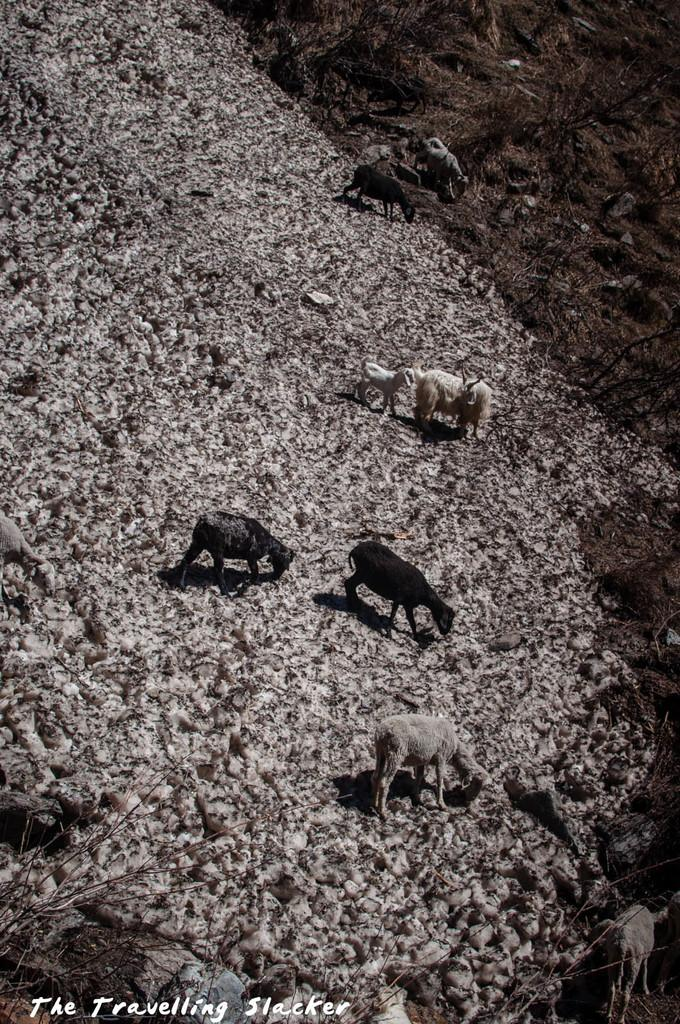What is happening in the image? There are animals on a path in the image. Can you describe any additional features of the image? There is a watermark on the image. What type of pin is being used to hold the skirt in the image? There is no pin or skirt present in the image; it features animals on a path and a watermark. What kind of machine can be seen operating in the background of the image? There is no machine present in the image; it only shows animals on a path and a watermark. 